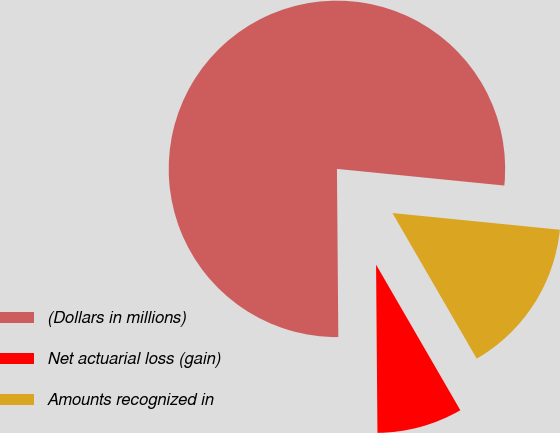Convert chart to OTSL. <chart><loc_0><loc_0><loc_500><loc_500><pie_chart><fcel>(Dollars in millions)<fcel>Net actuarial loss (gain)<fcel>Amounts recognized in<nl><fcel>76.71%<fcel>8.22%<fcel>15.07%<nl></chart> 